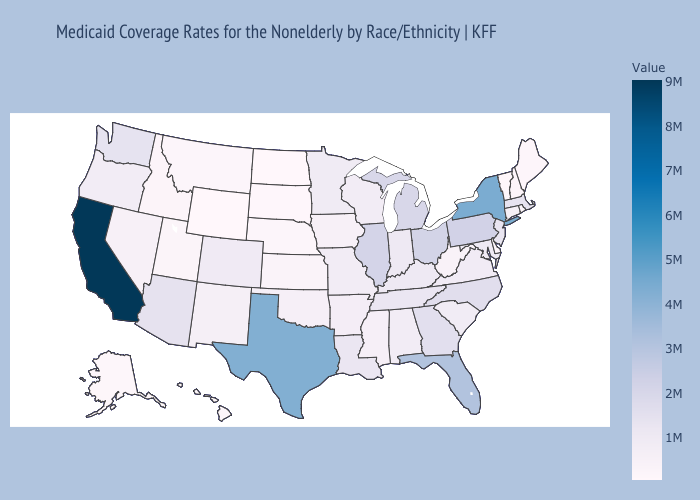Does New Jersey have the lowest value in the Northeast?
Keep it brief. No. Does Delaware have the highest value in the USA?
Short answer required. No. Among the states that border Utah , which have the lowest value?
Answer briefly. Wyoming. Does California have the highest value in the USA?
Concise answer only. Yes. Which states have the highest value in the USA?
Be succinct. California. 